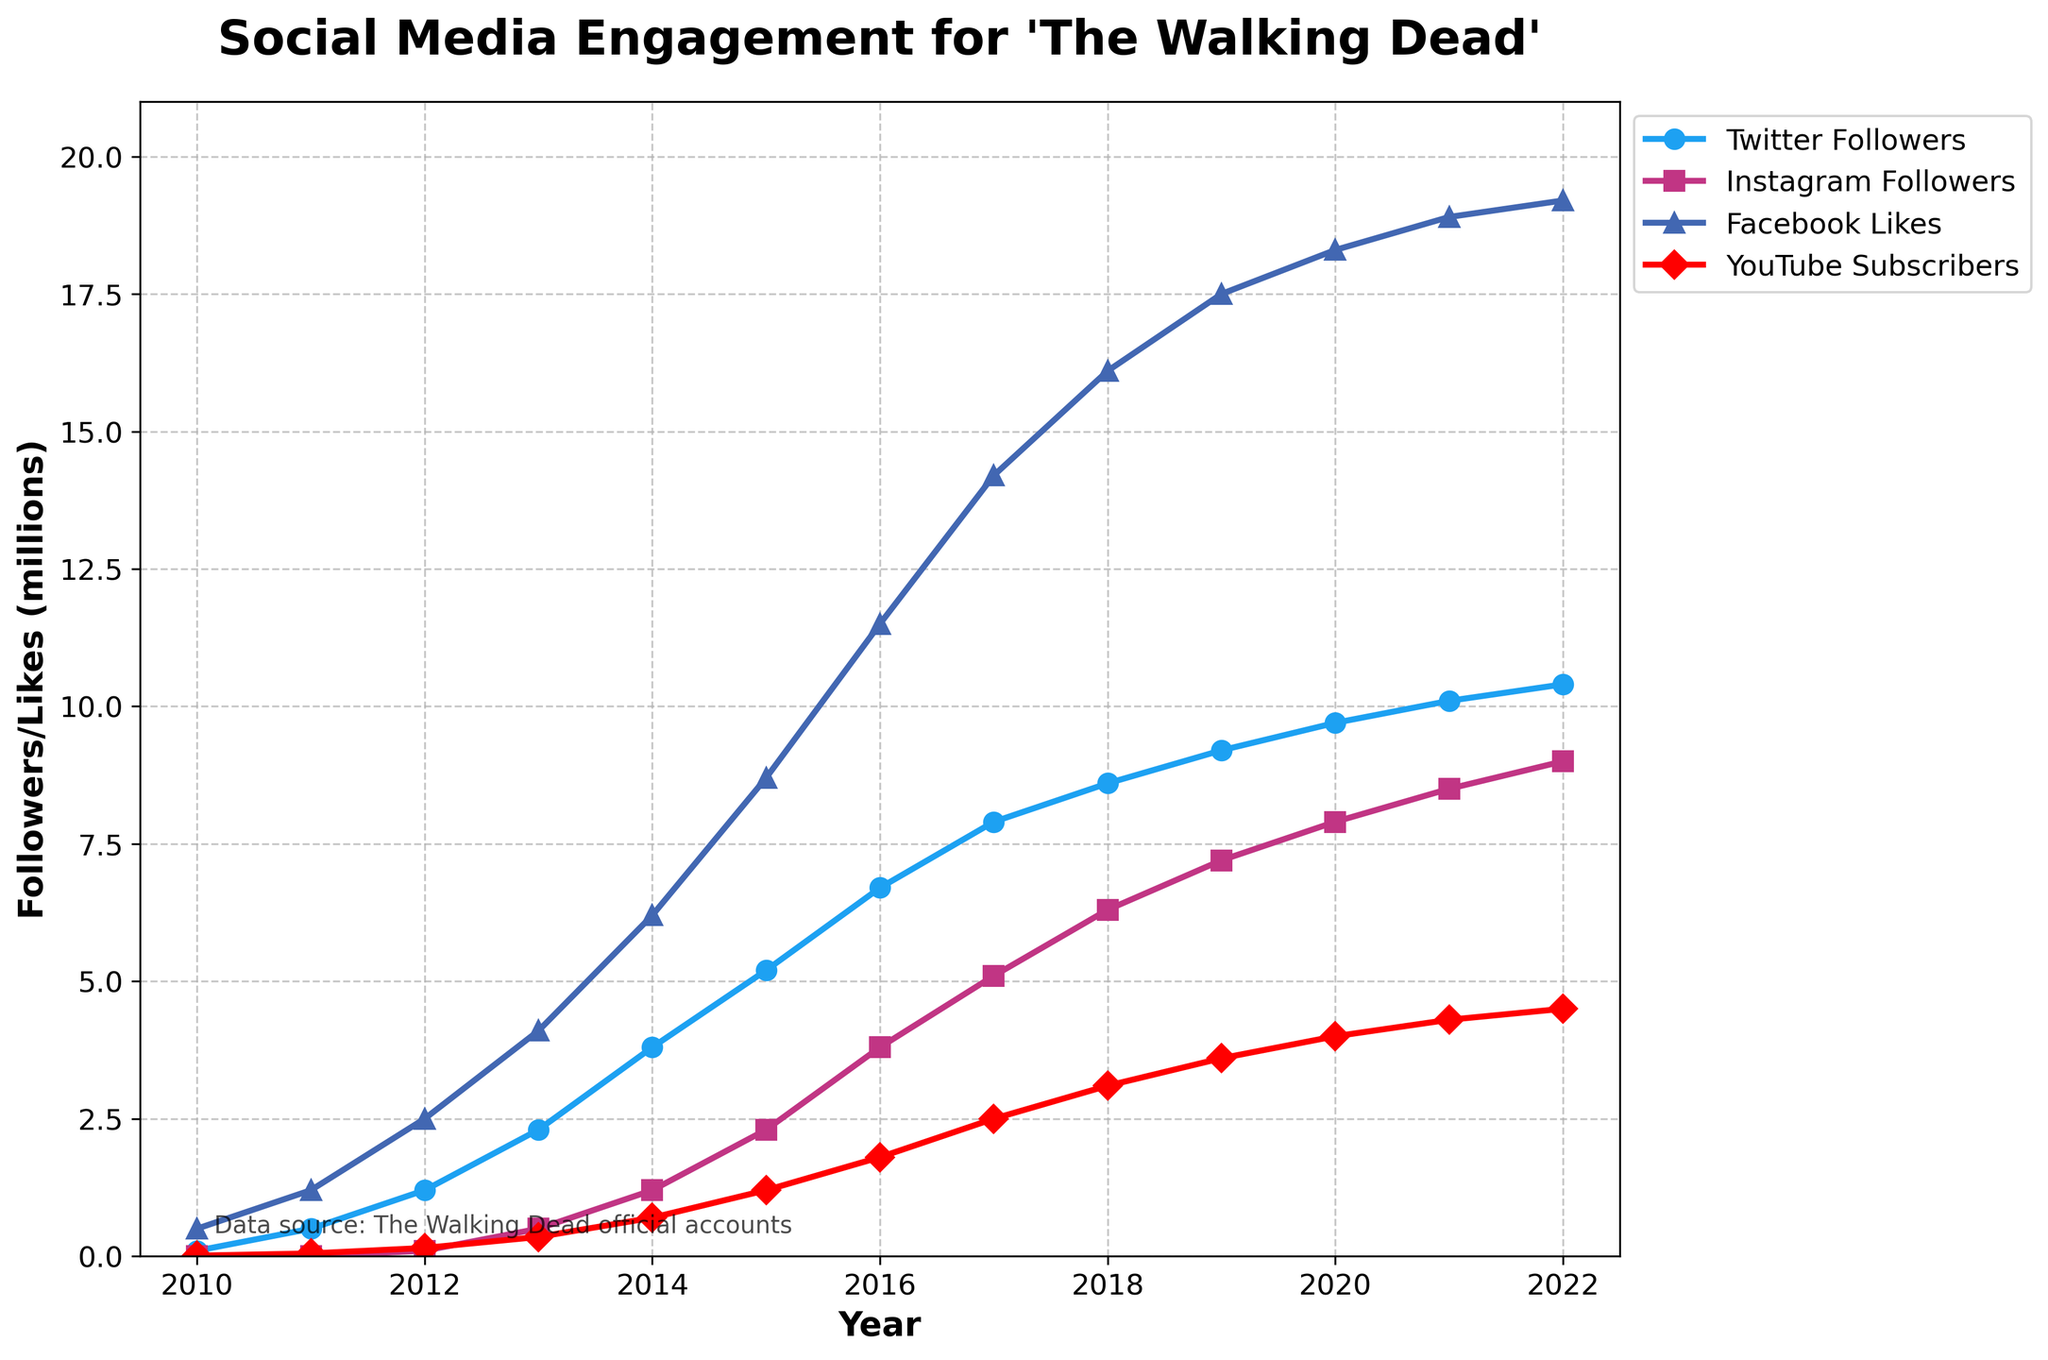What's the overall trend for Twitter followers from 2010 to 2022? By examining the line representing Twitter followers, it is clear that the number of followers has been increasing steadily from 0.1 million in 2010 to 10.4 million in 2022. There are no noticeable drops, indicating consistent growth.
Answer: Increasing Which social media platform had the highest number of followers/likes by 2022? To determine this, we compare the values in 2022 for each platform. Facebook had 19.2 million likes, Instagram had 9.0 million followers, Twitter had 10.4 million followers, and YouTube had 4.5 million subscribers. Facebook has the highest value.
Answer: Facebook In which year did Instagram followers first surpass 1 million, and how many followers were there that year? Looking at the Instagram line, we can see that Instagram followers first surpassed 1 million in 2014, when the number of followers reached 1.2 million.
Answer: 2014, 1.2 million Which platform showed the fastest growth in the first 3 years it was tracked? Instagram started being tracked from 2012. Between 2012 and 2014, Instagram grew from 0.1 million to 1.2 million. Comparing this to other platforms, similar early periods show slower growth. Therefore, Instagram showed the fastest growth initially.
Answer: Instagram How did the number of YouTube subscribers change from 2016 to 2018? Observing the data points and their corresponding markings for YouTube subscribers shows an increase from 1.8 million in 2016 to 3.1 million in 2018. This is an increase of 1.3 million subscribers over two years.
Answer: Increased by 1.3 million Between 2013 and 2015, which platform saw the largest increase in followers/likes, and by how much? From 2013 to 2015, Facebook likes increased from 4.1 million to 8.7 million, an increase of 4.6 million. Comparing this increase with Twitter, Instagram, and YouTube, no other platform saw such a large increase.
Answer: Facebook by 4.6 million What is the average number of Instagram followers for the years they were tracked? Instagram followers were tracked from 2012 to 2022. Calculating the average involves summing up the values (0.1 + 0.5 + 1.2 + 2.3 + 3.8 + 5.1 + 6.3 + 7.2 + 7.9 + 8.5 + 9.0) and dividing by the number of years (11). The average is (51.9/11) million, approximately 4.72 million.
Answer: 4.72 million Which platforms had more than 5 million followers/likes by the year 2017? Analyzing the platforms in 2017, we see that Facebook had 14.2 million likes, Twitter had 7.9 million followers, and Instagram had 5.1 million followers, all surpassing the 5 million mark. YouTube had 2.5 million subscribers, which is below 5 million.
Answer: Facebook, Twitter, Instagram 